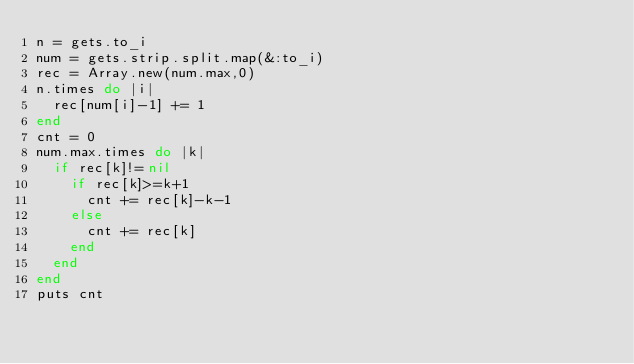Convert code to text. <code><loc_0><loc_0><loc_500><loc_500><_Ruby_>n = gets.to_i
num = gets.strip.split.map(&:to_i)
rec = Array.new(num.max,0)
n.times do |i|
  rec[num[i]-1] += 1
end
cnt = 0
num.max.times do |k|
  if rec[k]!=nil
    if rec[k]>=k+1
      cnt += rec[k]-k-1
    else
      cnt += rec[k]
    end
  end
end
puts cnt</code> 